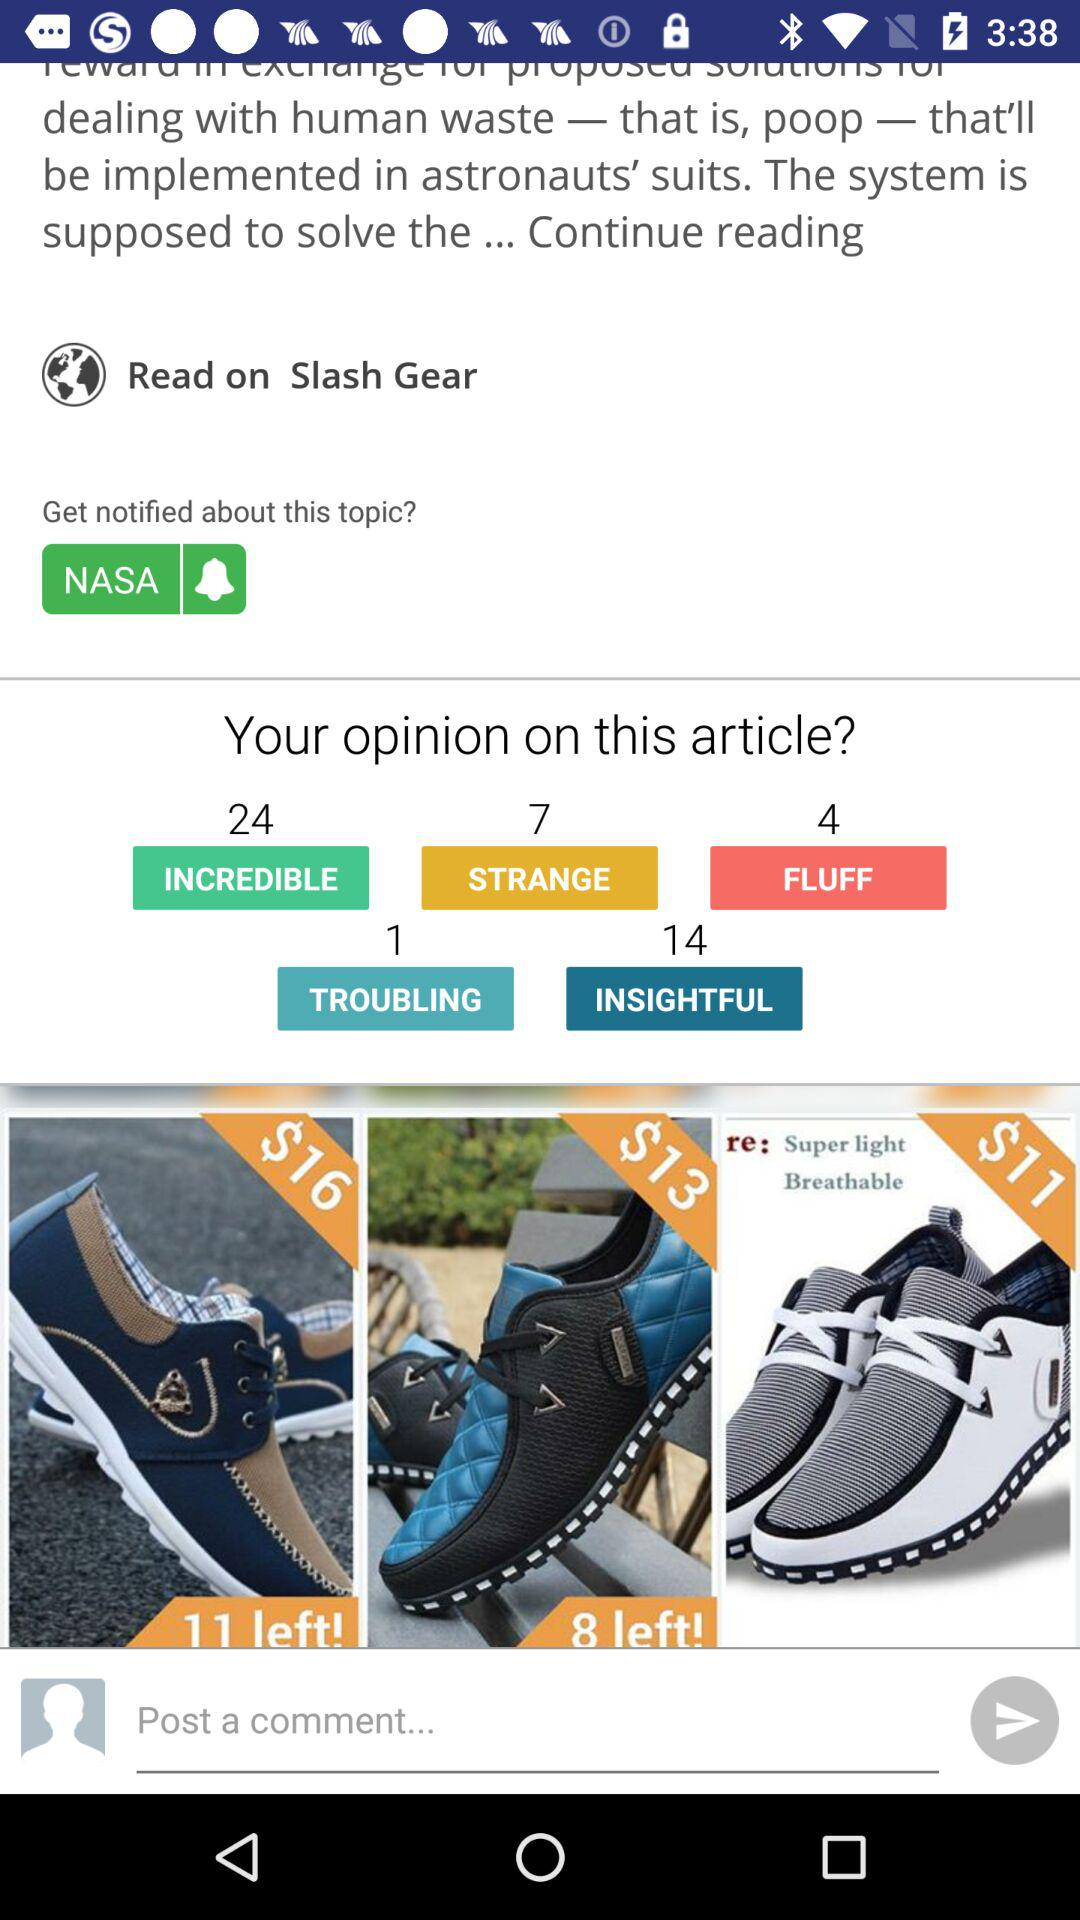What is the number of fluff opinions? The number is 4. 